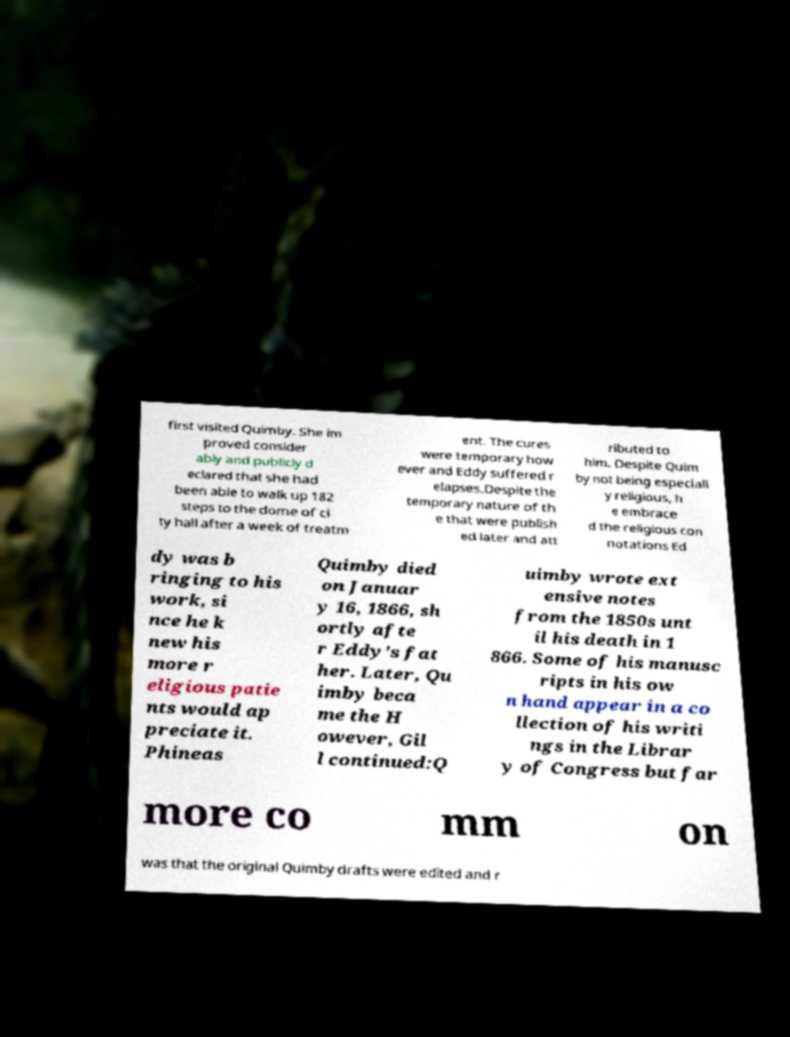For documentation purposes, I need the text within this image transcribed. Could you provide that? first visited Quimby. She im proved consider ably and publicly d eclared that she had been able to walk up 182 steps to the dome of ci ty hall after a week of treatm ent. The cures were temporary how ever and Eddy suffered r elapses.Despite the temporary nature of th e that were publish ed later and att ributed to him. Despite Quim by not being especiall y religious, h e embrace d the religious con notations Ed dy was b ringing to his work, si nce he k new his more r eligious patie nts would ap preciate it. Phineas Quimby died on Januar y 16, 1866, sh ortly afte r Eddy's fat her. Later, Qu imby beca me the H owever, Gil l continued:Q uimby wrote ext ensive notes from the 1850s unt il his death in 1 866. Some of his manusc ripts in his ow n hand appear in a co llection of his writi ngs in the Librar y of Congress but far more co mm on was that the original Quimby drafts were edited and r 